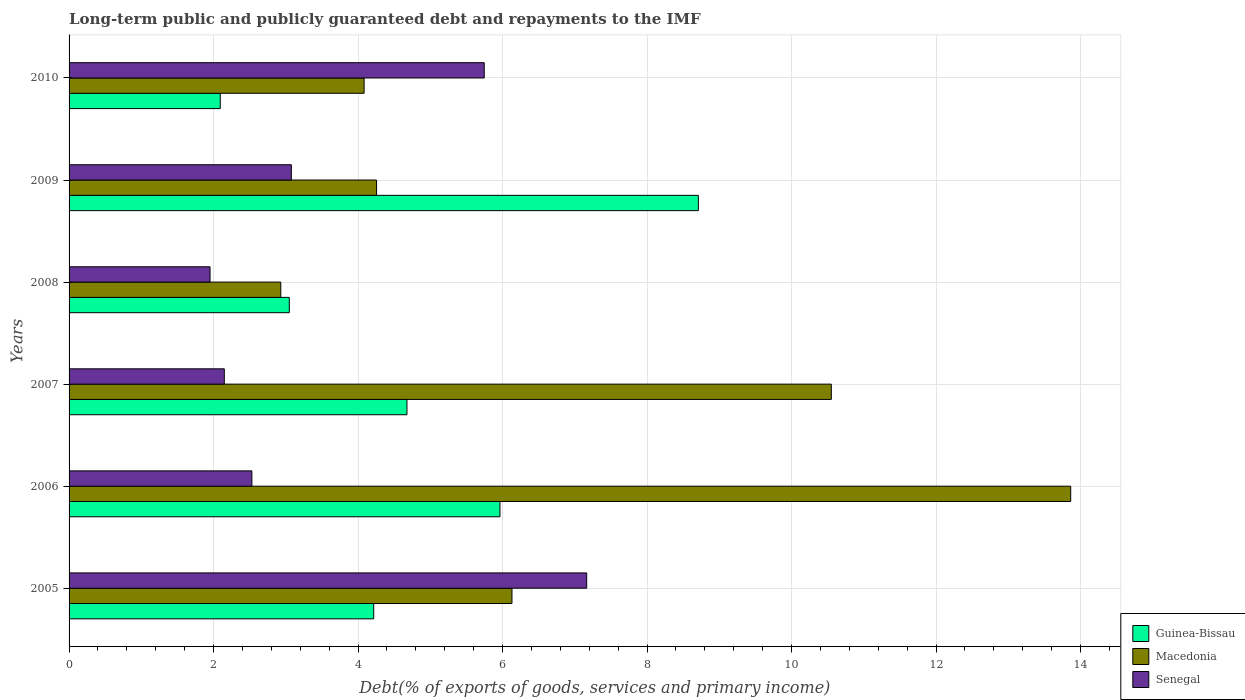Are the number of bars per tick equal to the number of legend labels?
Your answer should be compact. Yes. How many bars are there on the 6th tick from the top?
Give a very brief answer. 3. In how many cases, is the number of bars for a given year not equal to the number of legend labels?
Your answer should be compact. 0. What is the debt and repayments in Guinea-Bissau in 2008?
Ensure brevity in your answer.  3.05. Across all years, what is the maximum debt and repayments in Macedonia?
Provide a short and direct response. 13.86. Across all years, what is the minimum debt and repayments in Macedonia?
Your answer should be compact. 2.93. In which year was the debt and repayments in Senegal maximum?
Make the answer very short. 2005. What is the total debt and repayments in Guinea-Bissau in the graph?
Offer a very short reply. 28.71. What is the difference between the debt and repayments in Senegal in 2006 and that in 2007?
Give a very brief answer. 0.38. What is the difference between the debt and repayments in Macedonia in 2006 and the debt and repayments in Senegal in 2009?
Give a very brief answer. 10.79. What is the average debt and repayments in Senegal per year?
Give a very brief answer. 3.77. In the year 2008, what is the difference between the debt and repayments in Guinea-Bissau and debt and repayments in Senegal?
Your answer should be very brief. 1.1. What is the ratio of the debt and repayments in Macedonia in 2006 to that in 2007?
Make the answer very short. 1.31. What is the difference between the highest and the second highest debt and repayments in Senegal?
Offer a very short reply. 1.42. What is the difference between the highest and the lowest debt and repayments in Senegal?
Keep it short and to the point. 5.21. Is the sum of the debt and repayments in Senegal in 2008 and 2009 greater than the maximum debt and repayments in Macedonia across all years?
Make the answer very short. No. What does the 1st bar from the top in 2009 represents?
Ensure brevity in your answer.  Senegal. What does the 1st bar from the bottom in 2005 represents?
Make the answer very short. Guinea-Bissau. How many bars are there?
Make the answer very short. 18. Are all the bars in the graph horizontal?
Your response must be concise. Yes. Are the values on the major ticks of X-axis written in scientific E-notation?
Your answer should be very brief. No. Does the graph contain grids?
Keep it short and to the point. Yes. How many legend labels are there?
Make the answer very short. 3. How are the legend labels stacked?
Your answer should be compact. Vertical. What is the title of the graph?
Make the answer very short. Long-term public and publicly guaranteed debt and repayments to the IMF. What is the label or title of the X-axis?
Provide a short and direct response. Debt(% of exports of goods, services and primary income). What is the Debt(% of exports of goods, services and primary income) in Guinea-Bissau in 2005?
Offer a very short reply. 4.22. What is the Debt(% of exports of goods, services and primary income) in Macedonia in 2005?
Make the answer very short. 6.13. What is the Debt(% of exports of goods, services and primary income) of Senegal in 2005?
Offer a terse response. 7.16. What is the Debt(% of exports of goods, services and primary income) in Guinea-Bissau in 2006?
Your answer should be very brief. 5.96. What is the Debt(% of exports of goods, services and primary income) in Macedonia in 2006?
Provide a short and direct response. 13.86. What is the Debt(% of exports of goods, services and primary income) of Senegal in 2006?
Give a very brief answer. 2.53. What is the Debt(% of exports of goods, services and primary income) of Guinea-Bissau in 2007?
Keep it short and to the point. 4.68. What is the Debt(% of exports of goods, services and primary income) of Macedonia in 2007?
Provide a succinct answer. 10.55. What is the Debt(% of exports of goods, services and primary income) of Senegal in 2007?
Ensure brevity in your answer.  2.15. What is the Debt(% of exports of goods, services and primary income) of Guinea-Bissau in 2008?
Give a very brief answer. 3.05. What is the Debt(% of exports of goods, services and primary income) in Macedonia in 2008?
Ensure brevity in your answer.  2.93. What is the Debt(% of exports of goods, services and primary income) in Senegal in 2008?
Your answer should be compact. 1.95. What is the Debt(% of exports of goods, services and primary income) in Guinea-Bissau in 2009?
Provide a short and direct response. 8.71. What is the Debt(% of exports of goods, services and primary income) in Macedonia in 2009?
Provide a succinct answer. 4.26. What is the Debt(% of exports of goods, services and primary income) in Senegal in 2009?
Provide a short and direct response. 3.08. What is the Debt(% of exports of goods, services and primary income) in Guinea-Bissau in 2010?
Make the answer very short. 2.09. What is the Debt(% of exports of goods, services and primary income) in Macedonia in 2010?
Offer a very short reply. 4.08. What is the Debt(% of exports of goods, services and primary income) of Senegal in 2010?
Give a very brief answer. 5.75. Across all years, what is the maximum Debt(% of exports of goods, services and primary income) of Guinea-Bissau?
Keep it short and to the point. 8.71. Across all years, what is the maximum Debt(% of exports of goods, services and primary income) of Macedonia?
Your answer should be very brief. 13.86. Across all years, what is the maximum Debt(% of exports of goods, services and primary income) in Senegal?
Give a very brief answer. 7.16. Across all years, what is the minimum Debt(% of exports of goods, services and primary income) in Guinea-Bissau?
Provide a short and direct response. 2.09. Across all years, what is the minimum Debt(% of exports of goods, services and primary income) in Macedonia?
Ensure brevity in your answer.  2.93. Across all years, what is the minimum Debt(% of exports of goods, services and primary income) of Senegal?
Ensure brevity in your answer.  1.95. What is the total Debt(% of exports of goods, services and primary income) of Guinea-Bissau in the graph?
Your response must be concise. 28.71. What is the total Debt(% of exports of goods, services and primary income) of Macedonia in the graph?
Your response must be concise. 41.81. What is the total Debt(% of exports of goods, services and primary income) of Senegal in the graph?
Offer a terse response. 22.62. What is the difference between the Debt(% of exports of goods, services and primary income) of Guinea-Bissau in 2005 and that in 2006?
Your answer should be very brief. -1.75. What is the difference between the Debt(% of exports of goods, services and primary income) in Macedonia in 2005 and that in 2006?
Provide a succinct answer. -7.73. What is the difference between the Debt(% of exports of goods, services and primary income) in Senegal in 2005 and that in 2006?
Provide a short and direct response. 4.63. What is the difference between the Debt(% of exports of goods, services and primary income) of Guinea-Bissau in 2005 and that in 2007?
Provide a short and direct response. -0.46. What is the difference between the Debt(% of exports of goods, services and primary income) of Macedonia in 2005 and that in 2007?
Provide a short and direct response. -4.42. What is the difference between the Debt(% of exports of goods, services and primary income) of Senegal in 2005 and that in 2007?
Your answer should be compact. 5.02. What is the difference between the Debt(% of exports of goods, services and primary income) of Guinea-Bissau in 2005 and that in 2008?
Make the answer very short. 1.17. What is the difference between the Debt(% of exports of goods, services and primary income) in Senegal in 2005 and that in 2008?
Offer a terse response. 5.21. What is the difference between the Debt(% of exports of goods, services and primary income) of Guinea-Bissau in 2005 and that in 2009?
Provide a succinct answer. -4.49. What is the difference between the Debt(% of exports of goods, services and primary income) in Macedonia in 2005 and that in 2009?
Give a very brief answer. 1.87. What is the difference between the Debt(% of exports of goods, services and primary income) in Senegal in 2005 and that in 2009?
Make the answer very short. 4.09. What is the difference between the Debt(% of exports of goods, services and primary income) in Guinea-Bissau in 2005 and that in 2010?
Make the answer very short. 2.12. What is the difference between the Debt(% of exports of goods, services and primary income) in Macedonia in 2005 and that in 2010?
Give a very brief answer. 2.05. What is the difference between the Debt(% of exports of goods, services and primary income) of Senegal in 2005 and that in 2010?
Your answer should be compact. 1.42. What is the difference between the Debt(% of exports of goods, services and primary income) of Guinea-Bissau in 2006 and that in 2007?
Your response must be concise. 1.29. What is the difference between the Debt(% of exports of goods, services and primary income) of Macedonia in 2006 and that in 2007?
Give a very brief answer. 3.31. What is the difference between the Debt(% of exports of goods, services and primary income) of Senegal in 2006 and that in 2007?
Your response must be concise. 0.38. What is the difference between the Debt(% of exports of goods, services and primary income) of Guinea-Bissau in 2006 and that in 2008?
Provide a short and direct response. 2.92. What is the difference between the Debt(% of exports of goods, services and primary income) of Macedonia in 2006 and that in 2008?
Keep it short and to the point. 10.93. What is the difference between the Debt(% of exports of goods, services and primary income) in Senegal in 2006 and that in 2008?
Your answer should be very brief. 0.58. What is the difference between the Debt(% of exports of goods, services and primary income) in Guinea-Bissau in 2006 and that in 2009?
Provide a succinct answer. -2.75. What is the difference between the Debt(% of exports of goods, services and primary income) in Macedonia in 2006 and that in 2009?
Your answer should be compact. 9.61. What is the difference between the Debt(% of exports of goods, services and primary income) of Senegal in 2006 and that in 2009?
Give a very brief answer. -0.55. What is the difference between the Debt(% of exports of goods, services and primary income) of Guinea-Bissau in 2006 and that in 2010?
Ensure brevity in your answer.  3.87. What is the difference between the Debt(% of exports of goods, services and primary income) in Macedonia in 2006 and that in 2010?
Your answer should be compact. 9.78. What is the difference between the Debt(% of exports of goods, services and primary income) of Senegal in 2006 and that in 2010?
Keep it short and to the point. -3.22. What is the difference between the Debt(% of exports of goods, services and primary income) in Guinea-Bissau in 2007 and that in 2008?
Your response must be concise. 1.63. What is the difference between the Debt(% of exports of goods, services and primary income) of Macedonia in 2007 and that in 2008?
Ensure brevity in your answer.  7.62. What is the difference between the Debt(% of exports of goods, services and primary income) in Senegal in 2007 and that in 2008?
Offer a very short reply. 0.2. What is the difference between the Debt(% of exports of goods, services and primary income) of Guinea-Bissau in 2007 and that in 2009?
Your answer should be compact. -4.03. What is the difference between the Debt(% of exports of goods, services and primary income) in Macedonia in 2007 and that in 2009?
Offer a very short reply. 6.29. What is the difference between the Debt(% of exports of goods, services and primary income) in Senegal in 2007 and that in 2009?
Offer a terse response. -0.93. What is the difference between the Debt(% of exports of goods, services and primary income) in Guinea-Bissau in 2007 and that in 2010?
Your answer should be very brief. 2.58. What is the difference between the Debt(% of exports of goods, services and primary income) of Macedonia in 2007 and that in 2010?
Offer a terse response. 6.47. What is the difference between the Debt(% of exports of goods, services and primary income) in Senegal in 2007 and that in 2010?
Your answer should be very brief. -3.6. What is the difference between the Debt(% of exports of goods, services and primary income) of Guinea-Bissau in 2008 and that in 2009?
Provide a succinct answer. -5.66. What is the difference between the Debt(% of exports of goods, services and primary income) in Macedonia in 2008 and that in 2009?
Give a very brief answer. -1.33. What is the difference between the Debt(% of exports of goods, services and primary income) in Senegal in 2008 and that in 2009?
Provide a short and direct response. -1.13. What is the difference between the Debt(% of exports of goods, services and primary income) in Guinea-Bissau in 2008 and that in 2010?
Offer a very short reply. 0.96. What is the difference between the Debt(% of exports of goods, services and primary income) in Macedonia in 2008 and that in 2010?
Offer a very short reply. -1.15. What is the difference between the Debt(% of exports of goods, services and primary income) of Senegal in 2008 and that in 2010?
Ensure brevity in your answer.  -3.8. What is the difference between the Debt(% of exports of goods, services and primary income) of Guinea-Bissau in 2009 and that in 2010?
Provide a short and direct response. 6.62. What is the difference between the Debt(% of exports of goods, services and primary income) in Macedonia in 2009 and that in 2010?
Ensure brevity in your answer.  0.17. What is the difference between the Debt(% of exports of goods, services and primary income) in Senegal in 2009 and that in 2010?
Give a very brief answer. -2.67. What is the difference between the Debt(% of exports of goods, services and primary income) in Guinea-Bissau in 2005 and the Debt(% of exports of goods, services and primary income) in Macedonia in 2006?
Offer a very short reply. -9.65. What is the difference between the Debt(% of exports of goods, services and primary income) of Guinea-Bissau in 2005 and the Debt(% of exports of goods, services and primary income) of Senegal in 2006?
Keep it short and to the point. 1.69. What is the difference between the Debt(% of exports of goods, services and primary income) of Macedonia in 2005 and the Debt(% of exports of goods, services and primary income) of Senegal in 2006?
Make the answer very short. 3.6. What is the difference between the Debt(% of exports of goods, services and primary income) of Guinea-Bissau in 2005 and the Debt(% of exports of goods, services and primary income) of Macedonia in 2007?
Provide a short and direct response. -6.33. What is the difference between the Debt(% of exports of goods, services and primary income) in Guinea-Bissau in 2005 and the Debt(% of exports of goods, services and primary income) in Senegal in 2007?
Your response must be concise. 2.07. What is the difference between the Debt(% of exports of goods, services and primary income) of Macedonia in 2005 and the Debt(% of exports of goods, services and primary income) of Senegal in 2007?
Your answer should be very brief. 3.98. What is the difference between the Debt(% of exports of goods, services and primary income) in Guinea-Bissau in 2005 and the Debt(% of exports of goods, services and primary income) in Macedonia in 2008?
Ensure brevity in your answer.  1.29. What is the difference between the Debt(% of exports of goods, services and primary income) of Guinea-Bissau in 2005 and the Debt(% of exports of goods, services and primary income) of Senegal in 2008?
Offer a very short reply. 2.27. What is the difference between the Debt(% of exports of goods, services and primary income) of Macedonia in 2005 and the Debt(% of exports of goods, services and primary income) of Senegal in 2008?
Your response must be concise. 4.18. What is the difference between the Debt(% of exports of goods, services and primary income) of Guinea-Bissau in 2005 and the Debt(% of exports of goods, services and primary income) of Macedonia in 2009?
Give a very brief answer. -0.04. What is the difference between the Debt(% of exports of goods, services and primary income) of Guinea-Bissau in 2005 and the Debt(% of exports of goods, services and primary income) of Senegal in 2009?
Ensure brevity in your answer.  1.14. What is the difference between the Debt(% of exports of goods, services and primary income) in Macedonia in 2005 and the Debt(% of exports of goods, services and primary income) in Senegal in 2009?
Ensure brevity in your answer.  3.05. What is the difference between the Debt(% of exports of goods, services and primary income) in Guinea-Bissau in 2005 and the Debt(% of exports of goods, services and primary income) in Macedonia in 2010?
Provide a succinct answer. 0.13. What is the difference between the Debt(% of exports of goods, services and primary income) in Guinea-Bissau in 2005 and the Debt(% of exports of goods, services and primary income) in Senegal in 2010?
Ensure brevity in your answer.  -1.53. What is the difference between the Debt(% of exports of goods, services and primary income) of Macedonia in 2005 and the Debt(% of exports of goods, services and primary income) of Senegal in 2010?
Ensure brevity in your answer.  0.38. What is the difference between the Debt(% of exports of goods, services and primary income) in Guinea-Bissau in 2006 and the Debt(% of exports of goods, services and primary income) in Macedonia in 2007?
Give a very brief answer. -4.59. What is the difference between the Debt(% of exports of goods, services and primary income) in Guinea-Bissau in 2006 and the Debt(% of exports of goods, services and primary income) in Senegal in 2007?
Your answer should be very brief. 3.82. What is the difference between the Debt(% of exports of goods, services and primary income) of Macedonia in 2006 and the Debt(% of exports of goods, services and primary income) of Senegal in 2007?
Keep it short and to the point. 11.72. What is the difference between the Debt(% of exports of goods, services and primary income) in Guinea-Bissau in 2006 and the Debt(% of exports of goods, services and primary income) in Macedonia in 2008?
Make the answer very short. 3.03. What is the difference between the Debt(% of exports of goods, services and primary income) of Guinea-Bissau in 2006 and the Debt(% of exports of goods, services and primary income) of Senegal in 2008?
Provide a succinct answer. 4.01. What is the difference between the Debt(% of exports of goods, services and primary income) in Macedonia in 2006 and the Debt(% of exports of goods, services and primary income) in Senegal in 2008?
Keep it short and to the point. 11.91. What is the difference between the Debt(% of exports of goods, services and primary income) of Guinea-Bissau in 2006 and the Debt(% of exports of goods, services and primary income) of Macedonia in 2009?
Offer a very short reply. 1.71. What is the difference between the Debt(% of exports of goods, services and primary income) of Guinea-Bissau in 2006 and the Debt(% of exports of goods, services and primary income) of Senegal in 2009?
Give a very brief answer. 2.89. What is the difference between the Debt(% of exports of goods, services and primary income) in Macedonia in 2006 and the Debt(% of exports of goods, services and primary income) in Senegal in 2009?
Ensure brevity in your answer.  10.79. What is the difference between the Debt(% of exports of goods, services and primary income) in Guinea-Bissau in 2006 and the Debt(% of exports of goods, services and primary income) in Macedonia in 2010?
Give a very brief answer. 1.88. What is the difference between the Debt(% of exports of goods, services and primary income) of Guinea-Bissau in 2006 and the Debt(% of exports of goods, services and primary income) of Senegal in 2010?
Offer a terse response. 0.22. What is the difference between the Debt(% of exports of goods, services and primary income) in Macedonia in 2006 and the Debt(% of exports of goods, services and primary income) in Senegal in 2010?
Make the answer very short. 8.12. What is the difference between the Debt(% of exports of goods, services and primary income) in Guinea-Bissau in 2007 and the Debt(% of exports of goods, services and primary income) in Macedonia in 2008?
Give a very brief answer. 1.75. What is the difference between the Debt(% of exports of goods, services and primary income) in Guinea-Bissau in 2007 and the Debt(% of exports of goods, services and primary income) in Senegal in 2008?
Your response must be concise. 2.73. What is the difference between the Debt(% of exports of goods, services and primary income) in Macedonia in 2007 and the Debt(% of exports of goods, services and primary income) in Senegal in 2008?
Keep it short and to the point. 8.6. What is the difference between the Debt(% of exports of goods, services and primary income) in Guinea-Bissau in 2007 and the Debt(% of exports of goods, services and primary income) in Macedonia in 2009?
Ensure brevity in your answer.  0.42. What is the difference between the Debt(% of exports of goods, services and primary income) in Guinea-Bissau in 2007 and the Debt(% of exports of goods, services and primary income) in Senegal in 2009?
Ensure brevity in your answer.  1.6. What is the difference between the Debt(% of exports of goods, services and primary income) of Macedonia in 2007 and the Debt(% of exports of goods, services and primary income) of Senegal in 2009?
Your answer should be very brief. 7.47. What is the difference between the Debt(% of exports of goods, services and primary income) in Guinea-Bissau in 2007 and the Debt(% of exports of goods, services and primary income) in Macedonia in 2010?
Your answer should be compact. 0.59. What is the difference between the Debt(% of exports of goods, services and primary income) of Guinea-Bissau in 2007 and the Debt(% of exports of goods, services and primary income) of Senegal in 2010?
Provide a succinct answer. -1.07. What is the difference between the Debt(% of exports of goods, services and primary income) of Macedonia in 2007 and the Debt(% of exports of goods, services and primary income) of Senegal in 2010?
Offer a very short reply. 4.8. What is the difference between the Debt(% of exports of goods, services and primary income) of Guinea-Bissau in 2008 and the Debt(% of exports of goods, services and primary income) of Macedonia in 2009?
Make the answer very short. -1.21. What is the difference between the Debt(% of exports of goods, services and primary income) in Guinea-Bissau in 2008 and the Debt(% of exports of goods, services and primary income) in Senegal in 2009?
Give a very brief answer. -0.03. What is the difference between the Debt(% of exports of goods, services and primary income) of Macedonia in 2008 and the Debt(% of exports of goods, services and primary income) of Senegal in 2009?
Offer a very short reply. -0.15. What is the difference between the Debt(% of exports of goods, services and primary income) of Guinea-Bissau in 2008 and the Debt(% of exports of goods, services and primary income) of Macedonia in 2010?
Offer a very short reply. -1.04. What is the difference between the Debt(% of exports of goods, services and primary income) in Guinea-Bissau in 2008 and the Debt(% of exports of goods, services and primary income) in Senegal in 2010?
Offer a terse response. -2.7. What is the difference between the Debt(% of exports of goods, services and primary income) in Macedonia in 2008 and the Debt(% of exports of goods, services and primary income) in Senegal in 2010?
Your response must be concise. -2.82. What is the difference between the Debt(% of exports of goods, services and primary income) in Guinea-Bissau in 2009 and the Debt(% of exports of goods, services and primary income) in Macedonia in 2010?
Make the answer very short. 4.63. What is the difference between the Debt(% of exports of goods, services and primary income) of Guinea-Bissau in 2009 and the Debt(% of exports of goods, services and primary income) of Senegal in 2010?
Your response must be concise. 2.96. What is the difference between the Debt(% of exports of goods, services and primary income) of Macedonia in 2009 and the Debt(% of exports of goods, services and primary income) of Senegal in 2010?
Give a very brief answer. -1.49. What is the average Debt(% of exports of goods, services and primary income) in Guinea-Bissau per year?
Your answer should be compact. 4.78. What is the average Debt(% of exports of goods, services and primary income) of Macedonia per year?
Provide a short and direct response. 6.97. What is the average Debt(% of exports of goods, services and primary income) of Senegal per year?
Your answer should be very brief. 3.77. In the year 2005, what is the difference between the Debt(% of exports of goods, services and primary income) in Guinea-Bissau and Debt(% of exports of goods, services and primary income) in Macedonia?
Your response must be concise. -1.91. In the year 2005, what is the difference between the Debt(% of exports of goods, services and primary income) of Guinea-Bissau and Debt(% of exports of goods, services and primary income) of Senegal?
Keep it short and to the point. -2.95. In the year 2005, what is the difference between the Debt(% of exports of goods, services and primary income) in Macedonia and Debt(% of exports of goods, services and primary income) in Senegal?
Offer a terse response. -1.03. In the year 2006, what is the difference between the Debt(% of exports of goods, services and primary income) in Guinea-Bissau and Debt(% of exports of goods, services and primary income) in Macedonia?
Provide a short and direct response. -7.9. In the year 2006, what is the difference between the Debt(% of exports of goods, services and primary income) of Guinea-Bissau and Debt(% of exports of goods, services and primary income) of Senegal?
Ensure brevity in your answer.  3.43. In the year 2006, what is the difference between the Debt(% of exports of goods, services and primary income) in Macedonia and Debt(% of exports of goods, services and primary income) in Senegal?
Offer a very short reply. 11.33. In the year 2007, what is the difference between the Debt(% of exports of goods, services and primary income) in Guinea-Bissau and Debt(% of exports of goods, services and primary income) in Macedonia?
Provide a succinct answer. -5.87. In the year 2007, what is the difference between the Debt(% of exports of goods, services and primary income) in Guinea-Bissau and Debt(% of exports of goods, services and primary income) in Senegal?
Offer a very short reply. 2.53. In the year 2007, what is the difference between the Debt(% of exports of goods, services and primary income) of Macedonia and Debt(% of exports of goods, services and primary income) of Senegal?
Offer a terse response. 8.4. In the year 2008, what is the difference between the Debt(% of exports of goods, services and primary income) in Guinea-Bissau and Debt(% of exports of goods, services and primary income) in Macedonia?
Give a very brief answer. 0.12. In the year 2008, what is the difference between the Debt(% of exports of goods, services and primary income) of Guinea-Bissau and Debt(% of exports of goods, services and primary income) of Senegal?
Provide a succinct answer. 1.1. In the year 2008, what is the difference between the Debt(% of exports of goods, services and primary income) of Macedonia and Debt(% of exports of goods, services and primary income) of Senegal?
Provide a succinct answer. 0.98. In the year 2009, what is the difference between the Debt(% of exports of goods, services and primary income) of Guinea-Bissau and Debt(% of exports of goods, services and primary income) of Macedonia?
Provide a short and direct response. 4.45. In the year 2009, what is the difference between the Debt(% of exports of goods, services and primary income) in Guinea-Bissau and Debt(% of exports of goods, services and primary income) in Senegal?
Offer a very short reply. 5.63. In the year 2009, what is the difference between the Debt(% of exports of goods, services and primary income) of Macedonia and Debt(% of exports of goods, services and primary income) of Senegal?
Keep it short and to the point. 1.18. In the year 2010, what is the difference between the Debt(% of exports of goods, services and primary income) of Guinea-Bissau and Debt(% of exports of goods, services and primary income) of Macedonia?
Provide a succinct answer. -1.99. In the year 2010, what is the difference between the Debt(% of exports of goods, services and primary income) of Guinea-Bissau and Debt(% of exports of goods, services and primary income) of Senegal?
Offer a terse response. -3.65. In the year 2010, what is the difference between the Debt(% of exports of goods, services and primary income) of Macedonia and Debt(% of exports of goods, services and primary income) of Senegal?
Your answer should be compact. -1.66. What is the ratio of the Debt(% of exports of goods, services and primary income) in Guinea-Bissau in 2005 to that in 2006?
Your response must be concise. 0.71. What is the ratio of the Debt(% of exports of goods, services and primary income) in Macedonia in 2005 to that in 2006?
Your answer should be compact. 0.44. What is the ratio of the Debt(% of exports of goods, services and primary income) in Senegal in 2005 to that in 2006?
Offer a terse response. 2.83. What is the ratio of the Debt(% of exports of goods, services and primary income) of Guinea-Bissau in 2005 to that in 2007?
Keep it short and to the point. 0.9. What is the ratio of the Debt(% of exports of goods, services and primary income) in Macedonia in 2005 to that in 2007?
Offer a terse response. 0.58. What is the ratio of the Debt(% of exports of goods, services and primary income) of Senegal in 2005 to that in 2007?
Offer a terse response. 3.33. What is the ratio of the Debt(% of exports of goods, services and primary income) of Guinea-Bissau in 2005 to that in 2008?
Provide a succinct answer. 1.38. What is the ratio of the Debt(% of exports of goods, services and primary income) of Macedonia in 2005 to that in 2008?
Provide a short and direct response. 2.09. What is the ratio of the Debt(% of exports of goods, services and primary income) in Senegal in 2005 to that in 2008?
Keep it short and to the point. 3.67. What is the ratio of the Debt(% of exports of goods, services and primary income) of Guinea-Bissau in 2005 to that in 2009?
Your answer should be very brief. 0.48. What is the ratio of the Debt(% of exports of goods, services and primary income) of Macedonia in 2005 to that in 2009?
Offer a terse response. 1.44. What is the ratio of the Debt(% of exports of goods, services and primary income) in Senegal in 2005 to that in 2009?
Your response must be concise. 2.33. What is the ratio of the Debt(% of exports of goods, services and primary income) of Guinea-Bissau in 2005 to that in 2010?
Offer a very short reply. 2.02. What is the ratio of the Debt(% of exports of goods, services and primary income) in Macedonia in 2005 to that in 2010?
Offer a very short reply. 1.5. What is the ratio of the Debt(% of exports of goods, services and primary income) in Senegal in 2005 to that in 2010?
Provide a succinct answer. 1.25. What is the ratio of the Debt(% of exports of goods, services and primary income) of Guinea-Bissau in 2006 to that in 2007?
Offer a terse response. 1.28. What is the ratio of the Debt(% of exports of goods, services and primary income) of Macedonia in 2006 to that in 2007?
Keep it short and to the point. 1.31. What is the ratio of the Debt(% of exports of goods, services and primary income) in Senegal in 2006 to that in 2007?
Ensure brevity in your answer.  1.18. What is the ratio of the Debt(% of exports of goods, services and primary income) in Guinea-Bissau in 2006 to that in 2008?
Provide a succinct answer. 1.96. What is the ratio of the Debt(% of exports of goods, services and primary income) of Macedonia in 2006 to that in 2008?
Offer a very short reply. 4.73. What is the ratio of the Debt(% of exports of goods, services and primary income) of Senegal in 2006 to that in 2008?
Offer a terse response. 1.3. What is the ratio of the Debt(% of exports of goods, services and primary income) in Guinea-Bissau in 2006 to that in 2009?
Provide a short and direct response. 0.68. What is the ratio of the Debt(% of exports of goods, services and primary income) of Macedonia in 2006 to that in 2009?
Ensure brevity in your answer.  3.26. What is the ratio of the Debt(% of exports of goods, services and primary income) in Senegal in 2006 to that in 2009?
Keep it short and to the point. 0.82. What is the ratio of the Debt(% of exports of goods, services and primary income) in Guinea-Bissau in 2006 to that in 2010?
Provide a succinct answer. 2.85. What is the ratio of the Debt(% of exports of goods, services and primary income) in Macedonia in 2006 to that in 2010?
Give a very brief answer. 3.4. What is the ratio of the Debt(% of exports of goods, services and primary income) of Senegal in 2006 to that in 2010?
Your answer should be very brief. 0.44. What is the ratio of the Debt(% of exports of goods, services and primary income) of Guinea-Bissau in 2007 to that in 2008?
Your response must be concise. 1.53. What is the ratio of the Debt(% of exports of goods, services and primary income) of Macedonia in 2007 to that in 2008?
Your answer should be very brief. 3.6. What is the ratio of the Debt(% of exports of goods, services and primary income) of Senegal in 2007 to that in 2008?
Your response must be concise. 1.1. What is the ratio of the Debt(% of exports of goods, services and primary income) in Guinea-Bissau in 2007 to that in 2009?
Make the answer very short. 0.54. What is the ratio of the Debt(% of exports of goods, services and primary income) in Macedonia in 2007 to that in 2009?
Provide a short and direct response. 2.48. What is the ratio of the Debt(% of exports of goods, services and primary income) in Senegal in 2007 to that in 2009?
Your answer should be very brief. 0.7. What is the ratio of the Debt(% of exports of goods, services and primary income) of Guinea-Bissau in 2007 to that in 2010?
Provide a short and direct response. 2.24. What is the ratio of the Debt(% of exports of goods, services and primary income) in Macedonia in 2007 to that in 2010?
Your answer should be compact. 2.58. What is the ratio of the Debt(% of exports of goods, services and primary income) of Senegal in 2007 to that in 2010?
Ensure brevity in your answer.  0.37. What is the ratio of the Debt(% of exports of goods, services and primary income) in Macedonia in 2008 to that in 2009?
Ensure brevity in your answer.  0.69. What is the ratio of the Debt(% of exports of goods, services and primary income) in Senegal in 2008 to that in 2009?
Offer a very short reply. 0.63. What is the ratio of the Debt(% of exports of goods, services and primary income) of Guinea-Bissau in 2008 to that in 2010?
Give a very brief answer. 1.46. What is the ratio of the Debt(% of exports of goods, services and primary income) of Macedonia in 2008 to that in 2010?
Keep it short and to the point. 0.72. What is the ratio of the Debt(% of exports of goods, services and primary income) of Senegal in 2008 to that in 2010?
Offer a terse response. 0.34. What is the ratio of the Debt(% of exports of goods, services and primary income) of Guinea-Bissau in 2009 to that in 2010?
Offer a terse response. 4.16. What is the ratio of the Debt(% of exports of goods, services and primary income) in Macedonia in 2009 to that in 2010?
Provide a succinct answer. 1.04. What is the ratio of the Debt(% of exports of goods, services and primary income) of Senegal in 2009 to that in 2010?
Provide a succinct answer. 0.54. What is the difference between the highest and the second highest Debt(% of exports of goods, services and primary income) of Guinea-Bissau?
Keep it short and to the point. 2.75. What is the difference between the highest and the second highest Debt(% of exports of goods, services and primary income) of Macedonia?
Provide a short and direct response. 3.31. What is the difference between the highest and the second highest Debt(% of exports of goods, services and primary income) in Senegal?
Your answer should be compact. 1.42. What is the difference between the highest and the lowest Debt(% of exports of goods, services and primary income) in Guinea-Bissau?
Provide a succinct answer. 6.62. What is the difference between the highest and the lowest Debt(% of exports of goods, services and primary income) in Macedonia?
Provide a succinct answer. 10.93. What is the difference between the highest and the lowest Debt(% of exports of goods, services and primary income) of Senegal?
Your response must be concise. 5.21. 